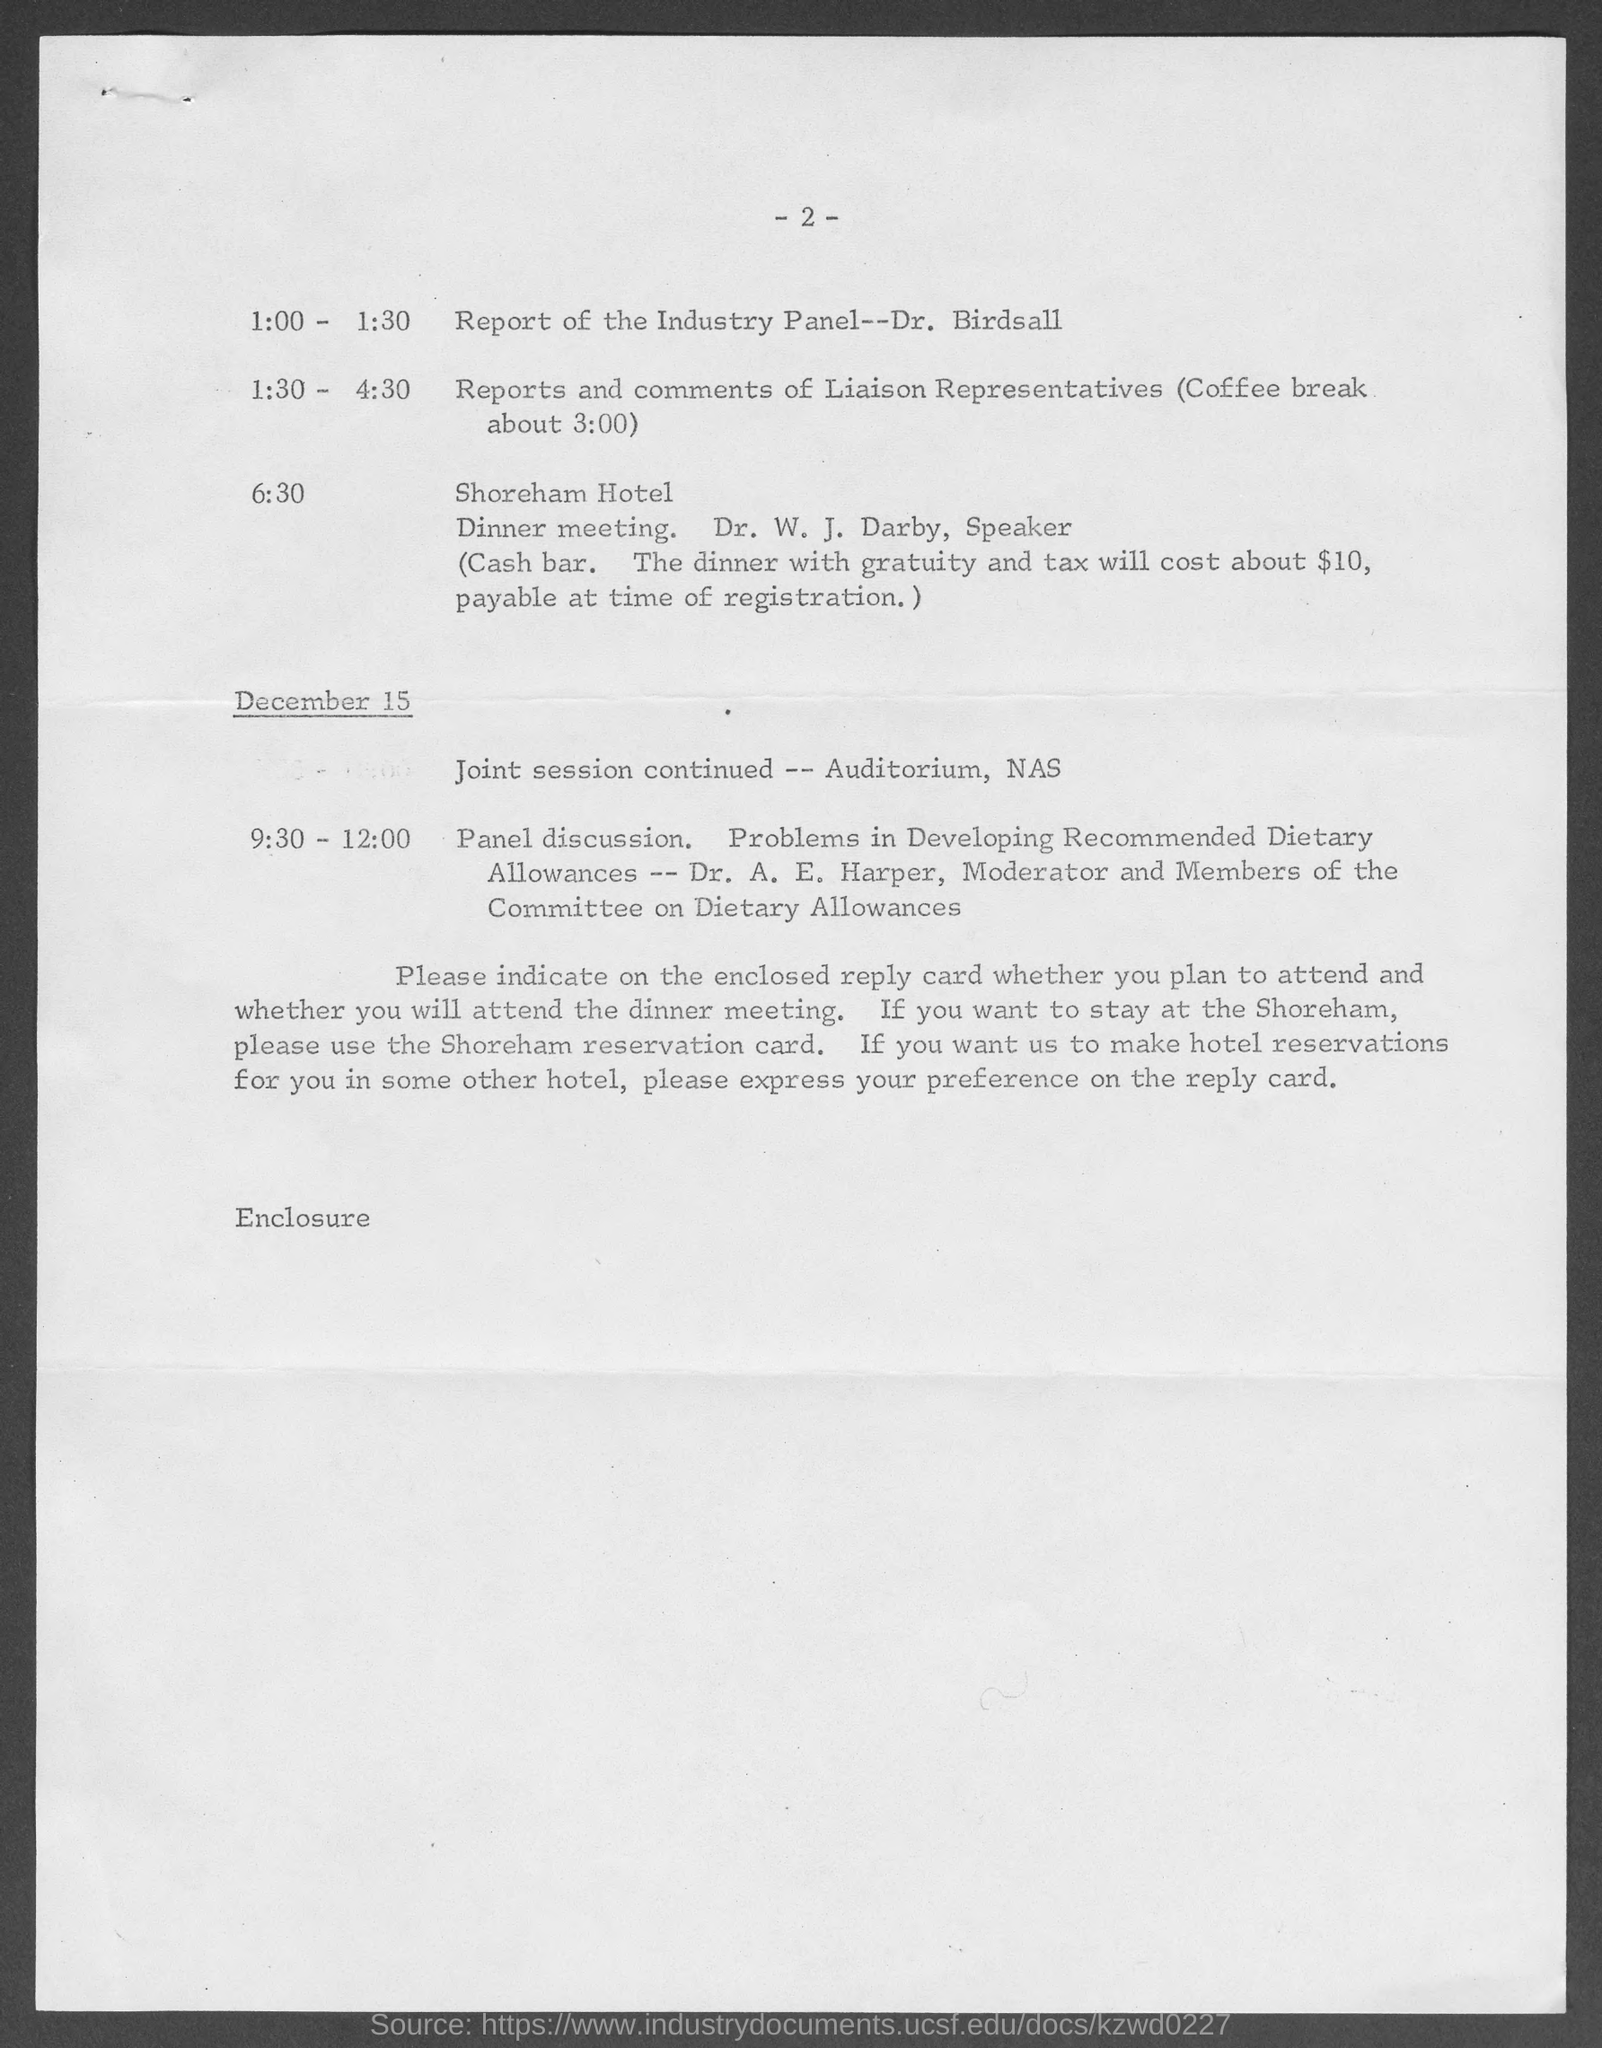What is the Page Number?
Your answer should be compact. - 2 -. What is the date mentioned in the document?
Your response must be concise. December 15. What is the name of the hotel?
Your answer should be compact. Shoreham. 